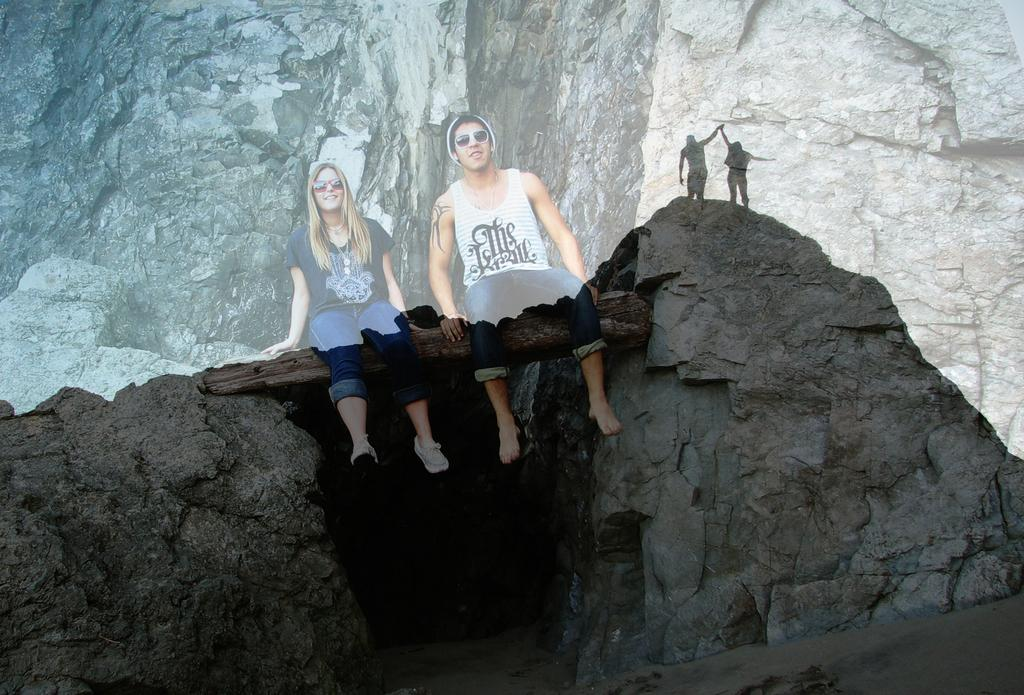What type of natural objects can be seen in the image? There are rocks in the image. What is placed between the rocks? There is a wooden log between the rocks. What are the two persons sitting on? The two persons are sitting on the wooden log. What are the persons wearing that might be used for eye protection? The persons are wearing goggles. What can be seen in the background of the image? There is a rock in the background of the image. How many people are standing in the image? Two people are standing in the image. What type of curtain can be seen hanging from the wooden log in the image? There is no curtain present in the image; it features rocks, a wooden log, and people wearing goggles. 